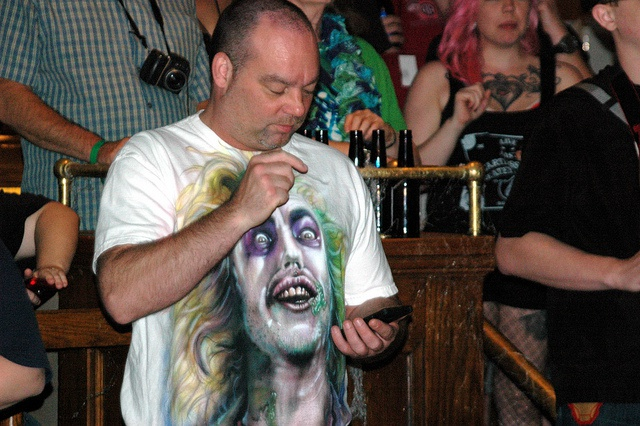Describe the objects in this image and their specific colors. I can see people in purple, lightgray, brown, darkgray, and black tones, people in purple, black, brown, and maroon tones, people in purple, gray, maroon, and black tones, people in purple, black, brown, maroon, and gray tones, and people in purple, black, darkgreen, teal, and brown tones in this image. 